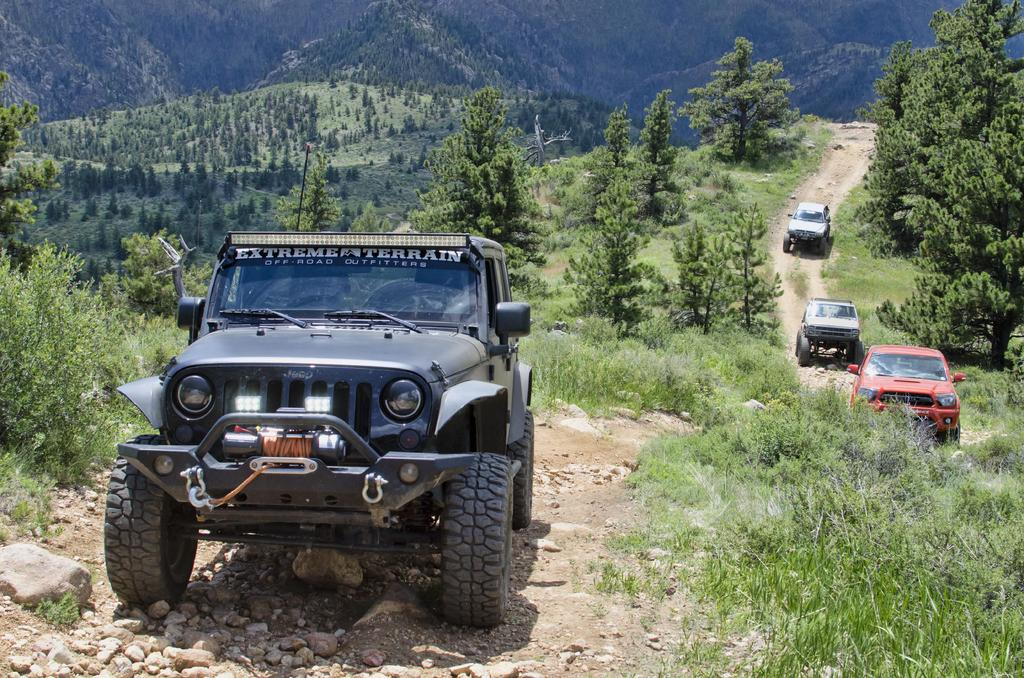What type of vegetation can be seen in the image? There is grass and trees in the image. What kind of surface is visible in the image? There is a path in the image. What is moving along the path in the image? There are vehicles on the path. Is there any text present in the image? Yes, there is text visible in the image. Can you see a door in the image? There is no door present in the image. Is there a battle taking place in the image? There is no battle depicted in the image. 